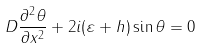<formula> <loc_0><loc_0><loc_500><loc_500>D \frac { \partial ^ { 2 } \theta } { \partial x ^ { 2 } } + 2 i ( \varepsilon + h ) \sin \theta = 0</formula> 